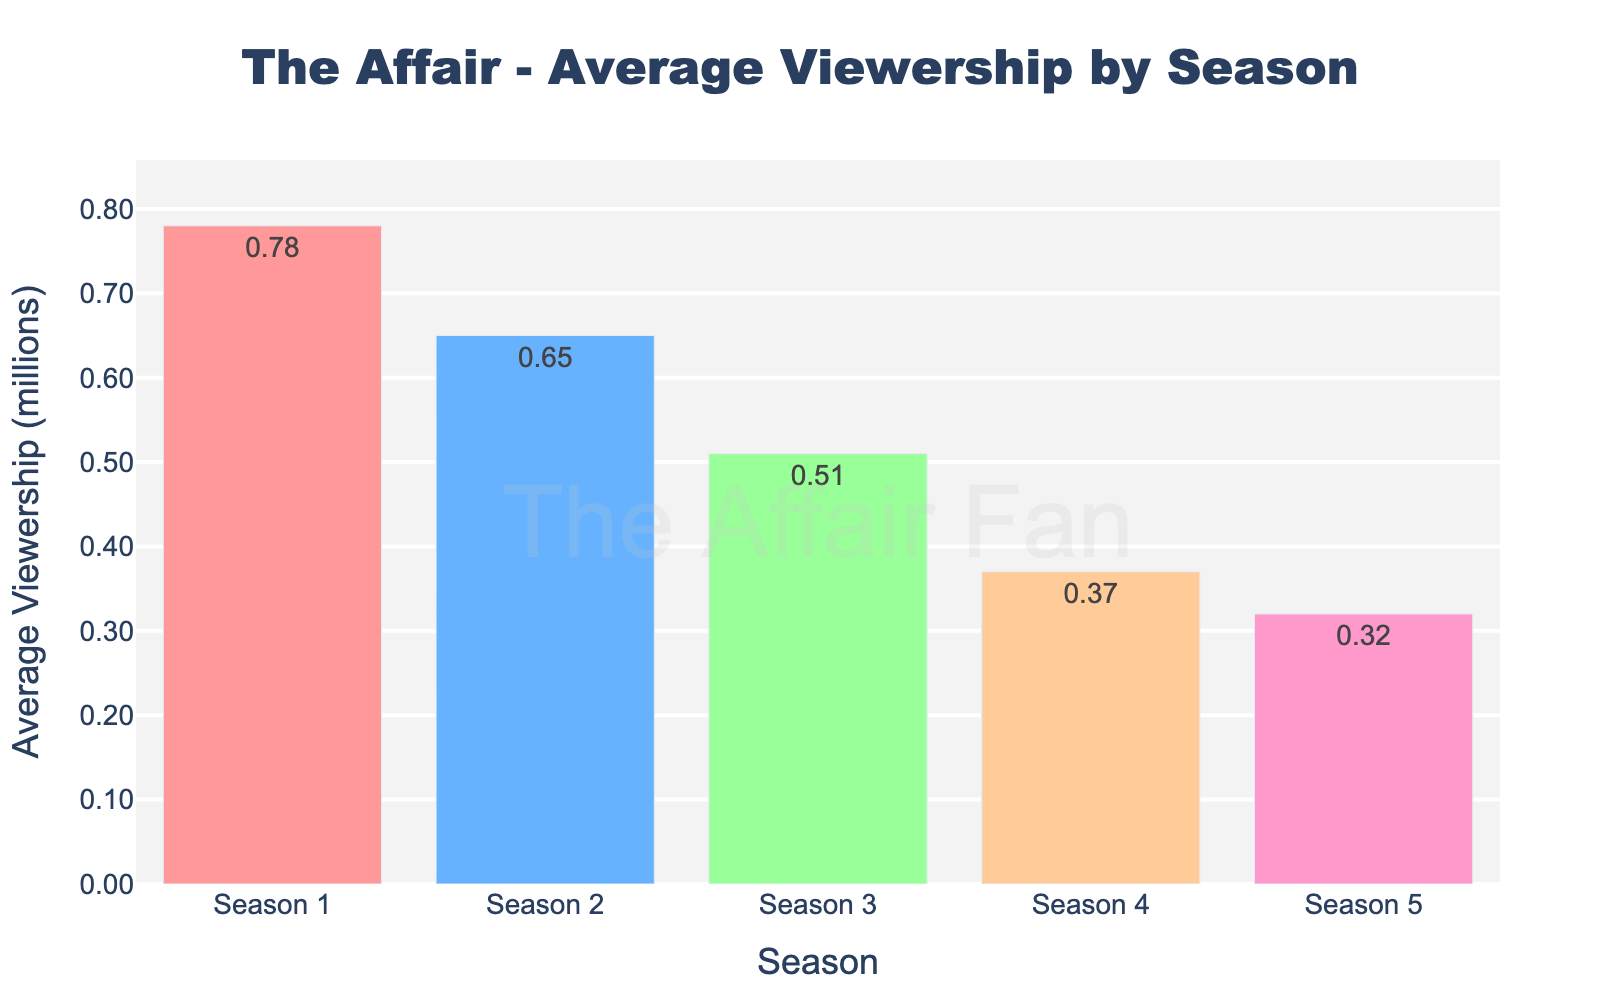what is the average viewership of Season 1? We look at the height of the bar labeled "Season 1" and see that the average viewership is 0.78 million.
Answer: 0.78 million How much lower is the viewership in Season 5 compared to Season 1? Subtract the viewership of Season 5 from that of Season 1 (0.78M - 0.32M).
Answer: 0.46 million less Which season had the lowest average viewership? We observe the shortest bar in the chart, which represents Season 5.
Answer: Season 5 What is the total viewership for all seasons combined? Add the viewership numbers for all the seasons (0.78M + 0.65M + 0.51M + 0.37M + 0.32M).
Answer: 2.63 million What is the percentage decrease in viewership from Season 4 to Season 5? Calculate the percentage decrease: ((0.37M - 0.32M) / 0.37M) * 100%.
Answer: 13.51% Which season had a viewership of 0.37 million? Check the bar chart and find the season that corresponds to the height of 0.37 million.
Answer: Season 4 How many seasons had a viewership below 0.50 million? Count the bars with height less than 0.50 million; these correspond to Seasons 3, 4, and 5.
Answer: 3 seasons What is the average viewership across all seasons? Sum the viewership numbers and divide by the number of seasons: (0.78M + 0.65M + 0.51M + 0.37M + 0.32M) / 5.
Answer: 0.526 million 